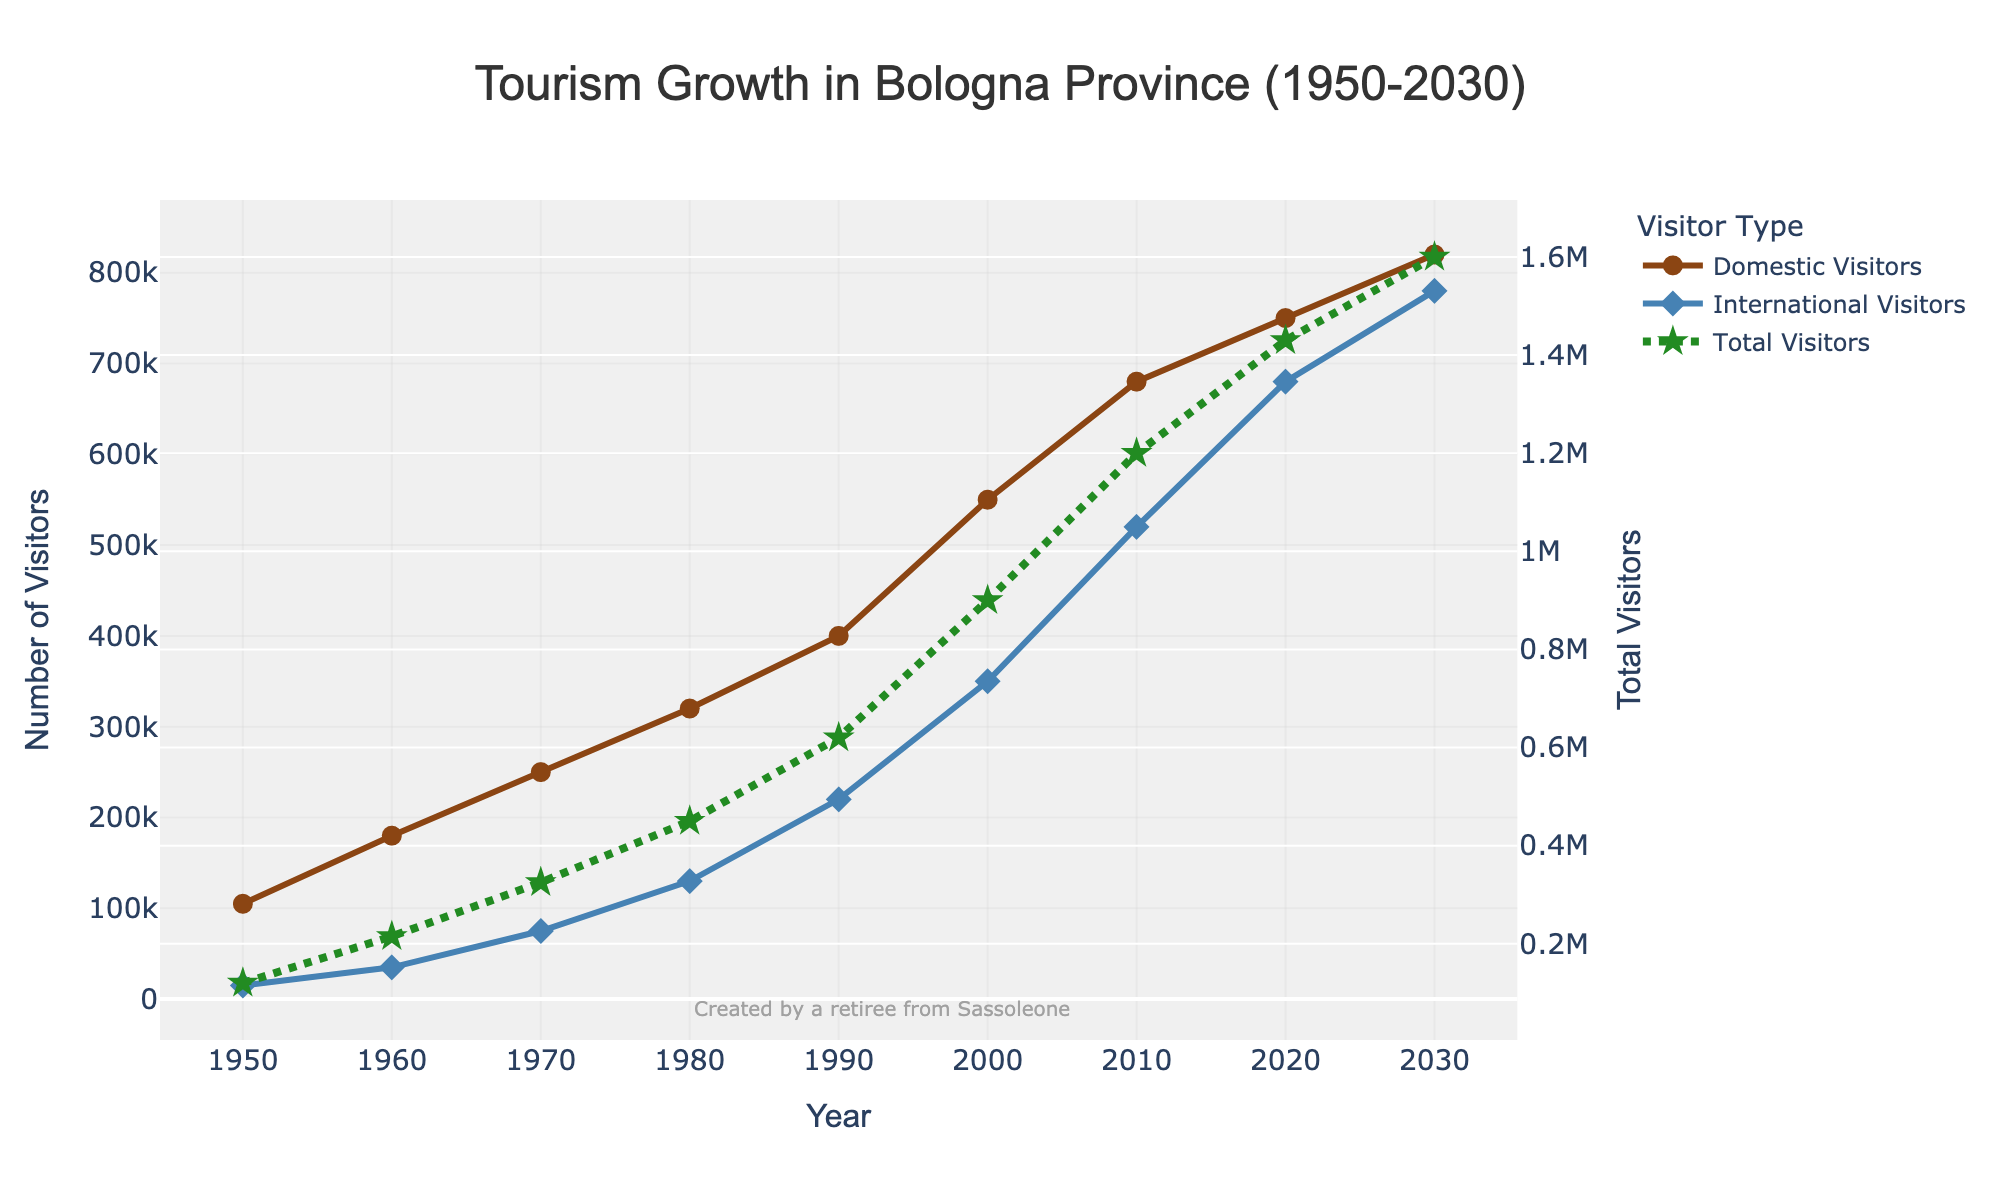What is the increase in the total number of visitors from 1950 to 2030? To find the increase, subtract the number of total visitors in 1950 from the number in 2030: 1600000 (2030) - 120000 (1950) = 1480000.
Answer: 1480000 Which year experienced a higher number of domestic visitors: 1990 or 2000? Compare the number of domestic visitors between the years 1990 and 2000. In 1990, there were 400000 domestic visitors, and in 2000, there were 550000. 550000 is greater than 400000.
Answer: 2000 What is the difference in the number of international visitors between 1960 and 2020? To find the difference, subtract the number of international visitors in 1960 from the number in 2020: 680000 (2020) - 35000 (1960) = 645000.
Answer: 645000 In which decade did the number of total visitors surpass the 1 million mark? Look at the total visitors data and find the first time it surpasses 1 million. In 2010, there were 1200000 total visitors, which is the first instance above 1 million.
Answer: 2010 What is the percentage increase in domestic visitors from 1950 to 2000? First, find the increase in the number of domestic visitors: 550000 (2000) - 105000 (1950) = 445000. Then, calculate the percentage increase: (445000 / 105000) * 100 = 423.81%.
Answer: 423.81% How does the growth rate of international visitors from 1950 to 1970 compare to the growth rate from 2000 to 2030? Calculate growth rates for each period. From 1950 to 1970: (75000 - 15000) / 15000 * 100 = 400%. From 2000 to 2030: (780000 - 350000) / 350000 * 100 = 122.86%. The growth rate from 1950 to 1970 is higher.
Answer: 1950 to 1970 Which type of visitors shows the highest growth from 1980 to 2010? Compare the growth of domestic and international visitors from 1980 to 2010. Domestic: 680000 (2010) - 320000 (1980) = 360000. International: 520000 (2010) - 130000 (1980) = 390000. International visitors show more growth.
Answer: International visitors How many international visitors are there in 1990 compared to domestic visitors in 1970? Look at the numbers: In 1990, there were 220000 international visitors. In 1970, there were 250000 domestic visitors. 220000 is less than 250000.
Answer: Less What is the average number of total visitors every decade starting from 1950 to 2030? Sum the total visitors for each decade and divide by the number of decades (9): (120000 + 215000 + 325000 + 450000 + 620000 + 900000 + 1200000 + 1430000 + 1600000) / 9 = 817222.22.
Answer: 817222.22 Which visitor type was consistently shown with a dashed-dot line? The dashed-dot line style is used for representing the total visitors throughout the figure.
Answer: Total visitors 